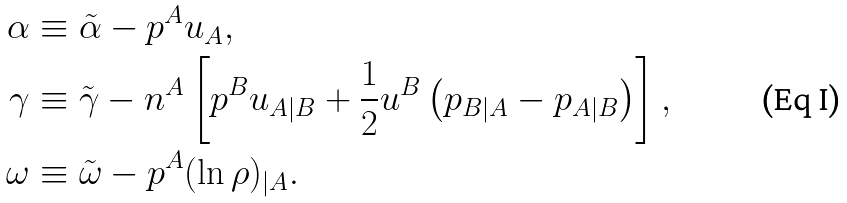Convert formula to latex. <formula><loc_0><loc_0><loc_500><loc_500>\alpha & \equiv \tilde { \alpha } - p ^ { A } u _ { A } , \\ \gamma & \equiv \tilde { \gamma } - n ^ { A } \left [ p ^ { B } u _ { A | B } + \frac { 1 } { 2 } u ^ { B } \left ( p _ { B | A } - p _ { A | B } \right ) \right ] , \\ \omega & \equiv \tilde { \omega } - p ^ { A } ( \ln \rho ) _ { | A } .</formula> 